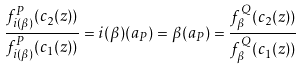<formula> <loc_0><loc_0><loc_500><loc_500>\frac { f _ { i ( \beta ) } ^ { P } ( c _ { 2 } ( z ) ) } { f _ { i ( \beta ) } ^ { P } ( c _ { 1 } ( z ) ) } = i ( \beta ) ( a _ { P } ) = \beta ( a _ { P } ) = \frac { f _ { \beta } ^ { Q } ( c _ { 2 } ( z ) ) } { f _ { \beta } ^ { Q } ( c _ { 1 } ( z ) ) }</formula> 